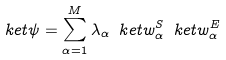<formula> <loc_0><loc_0><loc_500><loc_500>\ k e t { \psi } = \sum _ { \alpha = 1 } ^ { M } \lambda _ { \alpha } \ k e t { w ^ { S } _ { \alpha } } \ k e t { w ^ { E } _ { \alpha } }</formula> 